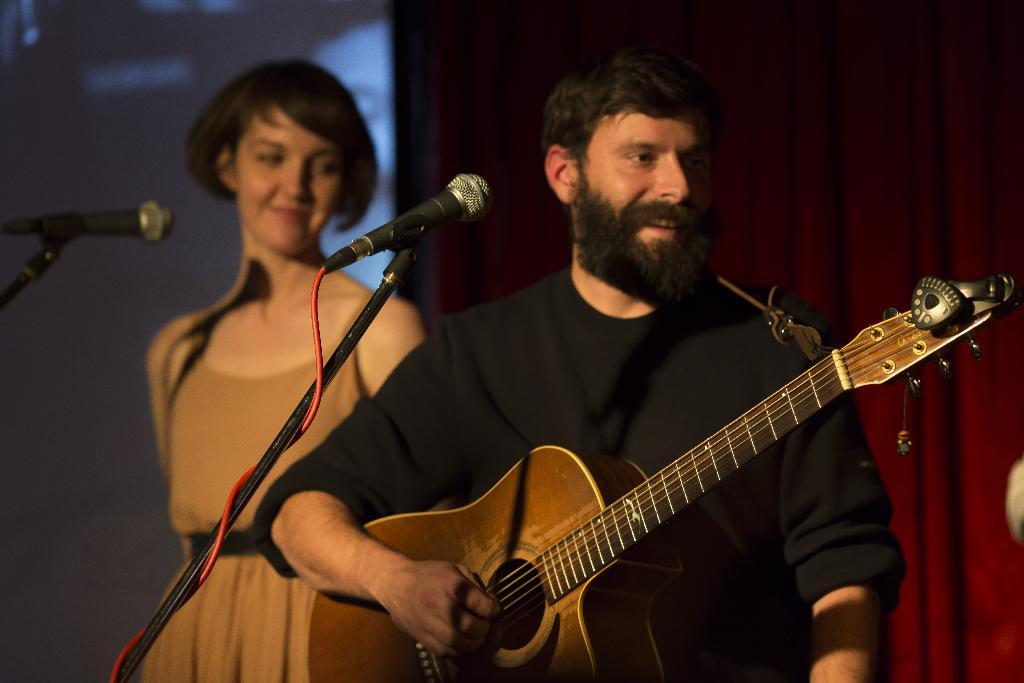What is the man in the image doing? The man is playing a guitar in the image. What object is the man positioned in front of? The man is in front of a microphone. Who else is present in the image? There is a girl in the image. Where is the girl located in relation to the man? The girl is beside the man. What type of bears can be seen interacting with the stem of the guitar in the image? There are no bears present in the image, and therefore no interaction with the guitar's stem can be observed. 